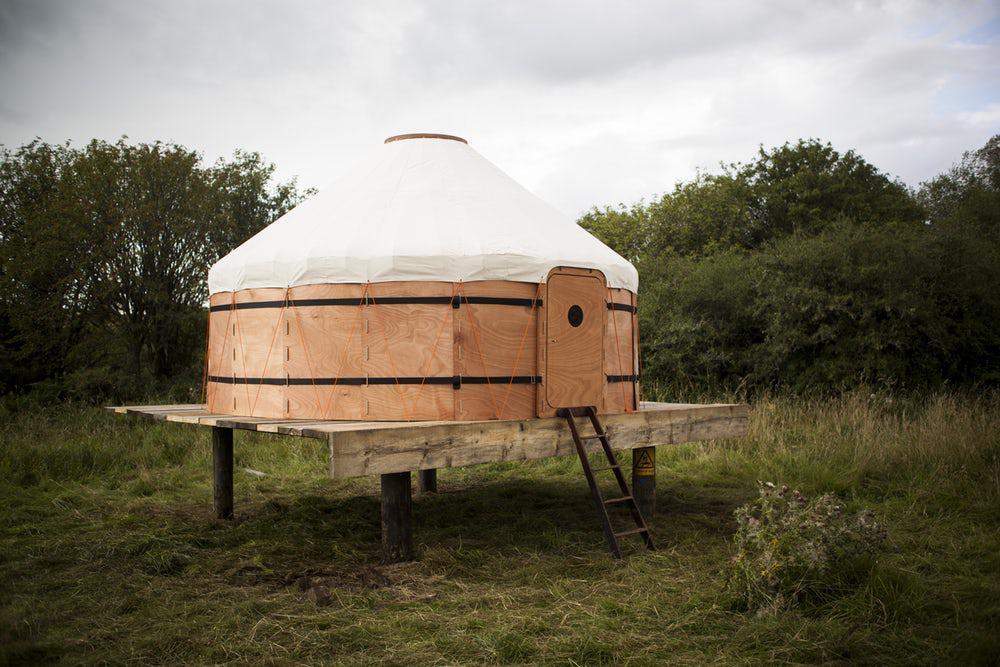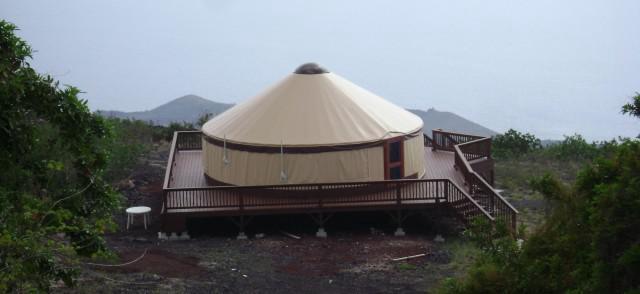The first image is the image on the left, the second image is the image on the right. Analyze the images presented: Is the assertion "There is at least one round window in the door in one of the images." valid? Answer yes or no. Yes. 